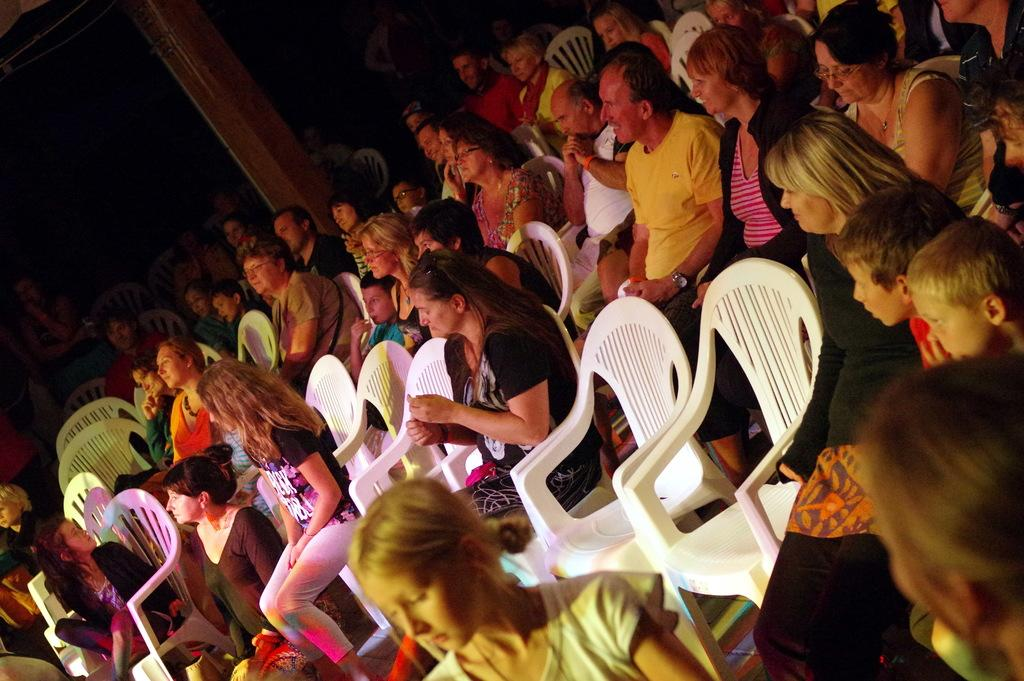What are the people in the image doing? The people in the image are sitting on white chairs. Can you describe any objects or structures in the image? Yes, there is a wooden pole in the left top of the image. What type of meal is being served in the basket in the image? There is no basket or meal present in the image. Can you describe the kitten playing with the wooden pole in the image? There is no kitten present in the image; only people sitting on chairs and a wooden pole are visible. 